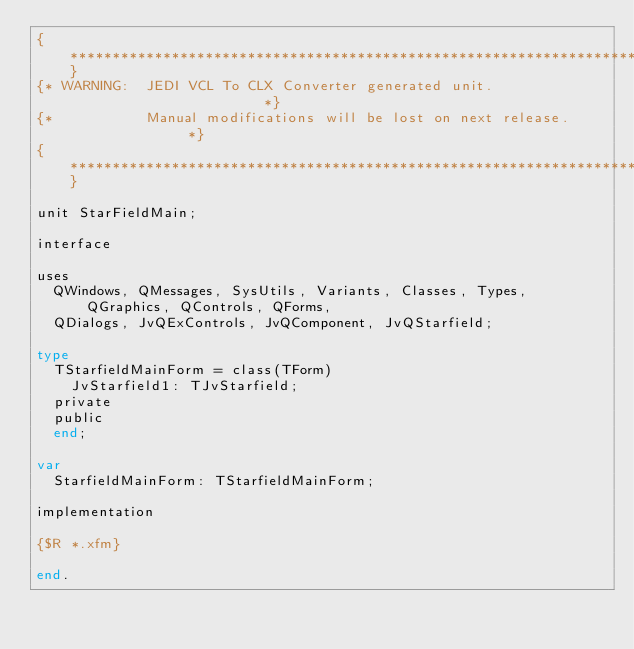<code> <loc_0><loc_0><loc_500><loc_500><_Pascal_>{******************************************************************************}
{* WARNING:  JEDI VCL To CLX Converter generated unit.                        *}
{*           Manual modifications will be lost on next release.               *}
{******************************************************************************}

unit StarFieldMain;

interface

uses
  QWindows, QMessages, SysUtils, Variants, Classes, Types, QGraphics, QControls, QForms,
  QDialogs, JvQExControls, JvQComponent, JvQStarfield;

type
  TStarfieldMainForm = class(TForm)
    JvStarfield1: TJvStarfield;
  private
  public
  end;

var
  StarfieldMainForm: TStarfieldMainForm;

implementation

{$R *.xfm}

end.
</code> 